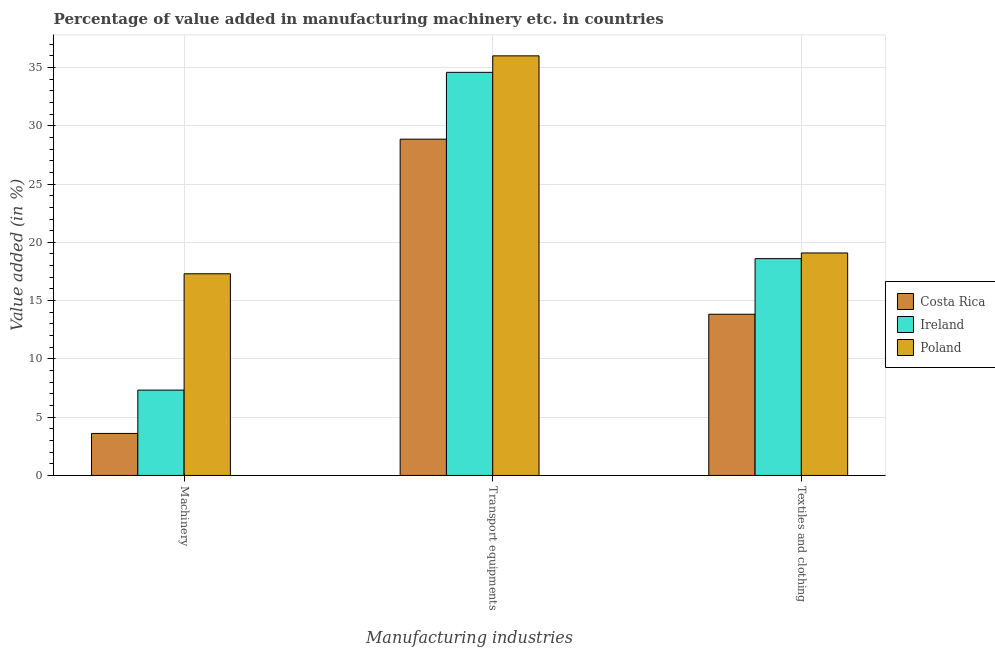How many different coloured bars are there?
Your answer should be compact. 3. How many groups of bars are there?
Provide a short and direct response. 3. Are the number of bars per tick equal to the number of legend labels?
Provide a succinct answer. Yes. Are the number of bars on each tick of the X-axis equal?
Provide a short and direct response. Yes. How many bars are there on the 3rd tick from the left?
Offer a very short reply. 3. How many bars are there on the 3rd tick from the right?
Provide a succinct answer. 3. What is the label of the 3rd group of bars from the left?
Make the answer very short. Textiles and clothing. What is the value added in manufacturing textile and clothing in Ireland?
Provide a succinct answer. 18.6. Across all countries, what is the maximum value added in manufacturing textile and clothing?
Offer a very short reply. 19.09. Across all countries, what is the minimum value added in manufacturing textile and clothing?
Your answer should be compact. 13.83. In which country was the value added in manufacturing textile and clothing maximum?
Your answer should be very brief. Poland. What is the total value added in manufacturing textile and clothing in the graph?
Give a very brief answer. 51.52. What is the difference between the value added in manufacturing textile and clothing in Costa Rica and that in Ireland?
Provide a short and direct response. -4.77. What is the difference between the value added in manufacturing transport equipments in Ireland and the value added in manufacturing machinery in Costa Rica?
Ensure brevity in your answer.  30.98. What is the average value added in manufacturing machinery per country?
Provide a succinct answer. 9.41. What is the difference between the value added in manufacturing transport equipments and value added in manufacturing machinery in Costa Rica?
Provide a succinct answer. 25.25. What is the ratio of the value added in manufacturing machinery in Poland to that in Costa Rica?
Your answer should be compact. 4.8. Is the difference between the value added in manufacturing textile and clothing in Costa Rica and Poland greater than the difference between the value added in manufacturing transport equipments in Costa Rica and Poland?
Offer a terse response. Yes. What is the difference between the highest and the second highest value added in manufacturing transport equipments?
Give a very brief answer. 1.41. What is the difference between the highest and the lowest value added in manufacturing textile and clothing?
Ensure brevity in your answer.  5.26. Is the sum of the value added in manufacturing transport equipments in Poland and Ireland greater than the maximum value added in manufacturing textile and clothing across all countries?
Your answer should be compact. Yes. What does the 2nd bar from the right in Machinery represents?
Your answer should be compact. Ireland. Are all the bars in the graph horizontal?
Offer a very short reply. No. What is the difference between two consecutive major ticks on the Y-axis?
Your answer should be compact. 5. Does the graph contain any zero values?
Make the answer very short. No. Where does the legend appear in the graph?
Your response must be concise. Center right. How are the legend labels stacked?
Offer a terse response. Vertical. What is the title of the graph?
Make the answer very short. Percentage of value added in manufacturing machinery etc. in countries. Does "Estonia" appear as one of the legend labels in the graph?
Ensure brevity in your answer.  No. What is the label or title of the X-axis?
Ensure brevity in your answer.  Manufacturing industries. What is the label or title of the Y-axis?
Provide a short and direct response. Value added (in %). What is the Value added (in %) of Costa Rica in Machinery?
Give a very brief answer. 3.61. What is the Value added (in %) in Ireland in Machinery?
Make the answer very short. 7.32. What is the Value added (in %) in Poland in Machinery?
Provide a short and direct response. 17.3. What is the Value added (in %) of Costa Rica in Transport equipments?
Keep it short and to the point. 28.85. What is the Value added (in %) of Ireland in Transport equipments?
Keep it short and to the point. 34.59. What is the Value added (in %) of Poland in Transport equipments?
Provide a short and direct response. 36. What is the Value added (in %) of Costa Rica in Textiles and clothing?
Offer a terse response. 13.83. What is the Value added (in %) of Ireland in Textiles and clothing?
Provide a short and direct response. 18.6. What is the Value added (in %) of Poland in Textiles and clothing?
Provide a succinct answer. 19.09. Across all Manufacturing industries, what is the maximum Value added (in %) in Costa Rica?
Provide a succinct answer. 28.85. Across all Manufacturing industries, what is the maximum Value added (in %) in Ireland?
Your answer should be compact. 34.59. Across all Manufacturing industries, what is the maximum Value added (in %) of Poland?
Ensure brevity in your answer.  36. Across all Manufacturing industries, what is the minimum Value added (in %) in Costa Rica?
Keep it short and to the point. 3.61. Across all Manufacturing industries, what is the minimum Value added (in %) of Ireland?
Give a very brief answer. 7.32. Across all Manufacturing industries, what is the minimum Value added (in %) in Poland?
Your answer should be compact. 17.3. What is the total Value added (in %) in Costa Rica in the graph?
Offer a terse response. 46.29. What is the total Value added (in %) of Ireland in the graph?
Offer a very short reply. 60.51. What is the total Value added (in %) in Poland in the graph?
Give a very brief answer. 72.39. What is the difference between the Value added (in %) in Costa Rica in Machinery and that in Transport equipments?
Your answer should be compact. -25.25. What is the difference between the Value added (in %) in Ireland in Machinery and that in Transport equipments?
Make the answer very short. -27.26. What is the difference between the Value added (in %) of Poland in Machinery and that in Transport equipments?
Make the answer very short. -18.7. What is the difference between the Value added (in %) in Costa Rica in Machinery and that in Textiles and clothing?
Your answer should be compact. -10.23. What is the difference between the Value added (in %) in Ireland in Machinery and that in Textiles and clothing?
Make the answer very short. -11.28. What is the difference between the Value added (in %) in Poland in Machinery and that in Textiles and clothing?
Provide a short and direct response. -1.79. What is the difference between the Value added (in %) of Costa Rica in Transport equipments and that in Textiles and clothing?
Give a very brief answer. 15.02. What is the difference between the Value added (in %) in Ireland in Transport equipments and that in Textiles and clothing?
Your answer should be compact. 15.99. What is the difference between the Value added (in %) in Poland in Transport equipments and that in Textiles and clothing?
Keep it short and to the point. 16.91. What is the difference between the Value added (in %) of Costa Rica in Machinery and the Value added (in %) of Ireland in Transport equipments?
Provide a succinct answer. -30.98. What is the difference between the Value added (in %) of Costa Rica in Machinery and the Value added (in %) of Poland in Transport equipments?
Your response must be concise. -32.4. What is the difference between the Value added (in %) in Ireland in Machinery and the Value added (in %) in Poland in Transport equipments?
Provide a succinct answer. -28.68. What is the difference between the Value added (in %) of Costa Rica in Machinery and the Value added (in %) of Ireland in Textiles and clothing?
Make the answer very short. -15. What is the difference between the Value added (in %) of Costa Rica in Machinery and the Value added (in %) of Poland in Textiles and clothing?
Offer a terse response. -15.48. What is the difference between the Value added (in %) of Ireland in Machinery and the Value added (in %) of Poland in Textiles and clothing?
Give a very brief answer. -11.77. What is the difference between the Value added (in %) of Costa Rica in Transport equipments and the Value added (in %) of Ireland in Textiles and clothing?
Give a very brief answer. 10.25. What is the difference between the Value added (in %) of Costa Rica in Transport equipments and the Value added (in %) of Poland in Textiles and clothing?
Give a very brief answer. 9.76. What is the difference between the Value added (in %) of Ireland in Transport equipments and the Value added (in %) of Poland in Textiles and clothing?
Provide a short and direct response. 15.5. What is the average Value added (in %) in Costa Rica per Manufacturing industries?
Your answer should be very brief. 15.43. What is the average Value added (in %) in Ireland per Manufacturing industries?
Your answer should be very brief. 20.17. What is the average Value added (in %) of Poland per Manufacturing industries?
Offer a terse response. 24.13. What is the difference between the Value added (in %) of Costa Rica and Value added (in %) of Ireland in Machinery?
Offer a terse response. -3.72. What is the difference between the Value added (in %) in Costa Rica and Value added (in %) in Poland in Machinery?
Keep it short and to the point. -13.7. What is the difference between the Value added (in %) of Ireland and Value added (in %) of Poland in Machinery?
Offer a very short reply. -9.98. What is the difference between the Value added (in %) in Costa Rica and Value added (in %) in Ireland in Transport equipments?
Make the answer very short. -5.73. What is the difference between the Value added (in %) in Costa Rica and Value added (in %) in Poland in Transport equipments?
Provide a succinct answer. -7.15. What is the difference between the Value added (in %) of Ireland and Value added (in %) of Poland in Transport equipments?
Your response must be concise. -1.41. What is the difference between the Value added (in %) in Costa Rica and Value added (in %) in Ireland in Textiles and clothing?
Offer a very short reply. -4.77. What is the difference between the Value added (in %) of Costa Rica and Value added (in %) of Poland in Textiles and clothing?
Ensure brevity in your answer.  -5.26. What is the difference between the Value added (in %) in Ireland and Value added (in %) in Poland in Textiles and clothing?
Give a very brief answer. -0.49. What is the ratio of the Value added (in %) in Costa Rica in Machinery to that in Transport equipments?
Offer a terse response. 0.12. What is the ratio of the Value added (in %) in Ireland in Machinery to that in Transport equipments?
Offer a terse response. 0.21. What is the ratio of the Value added (in %) of Poland in Machinery to that in Transport equipments?
Your response must be concise. 0.48. What is the ratio of the Value added (in %) of Costa Rica in Machinery to that in Textiles and clothing?
Keep it short and to the point. 0.26. What is the ratio of the Value added (in %) in Ireland in Machinery to that in Textiles and clothing?
Your response must be concise. 0.39. What is the ratio of the Value added (in %) of Poland in Machinery to that in Textiles and clothing?
Provide a short and direct response. 0.91. What is the ratio of the Value added (in %) of Costa Rica in Transport equipments to that in Textiles and clothing?
Give a very brief answer. 2.09. What is the ratio of the Value added (in %) in Ireland in Transport equipments to that in Textiles and clothing?
Ensure brevity in your answer.  1.86. What is the ratio of the Value added (in %) in Poland in Transport equipments to that in Textiles and clothing?
Ensure brevity in your answer.  1.89. What is the difference between the highest and the second highest Value added (in %) in Costa Rica?
Provide a short and direct response. 15.02. What is the difference between the highest and the second highest Value added (in %) in Ireland?
Your answer should be compact. 15.99. What is the difference between the highest and the second highest Value added (in %) in Poland?
Your response must be concise. 16.91. What is the difference between the highest and the lowest Value added (in %) of Costa Rica?
Make the answer very short. 25.25. What is the difference between the highest and the lowest Value added (in %) of Ireland?
Keep it short and to the point. 27.26. What is the difference between the highest and the lowest Value added (in %) in Poland?
Give a very brief answer. 18.7. 